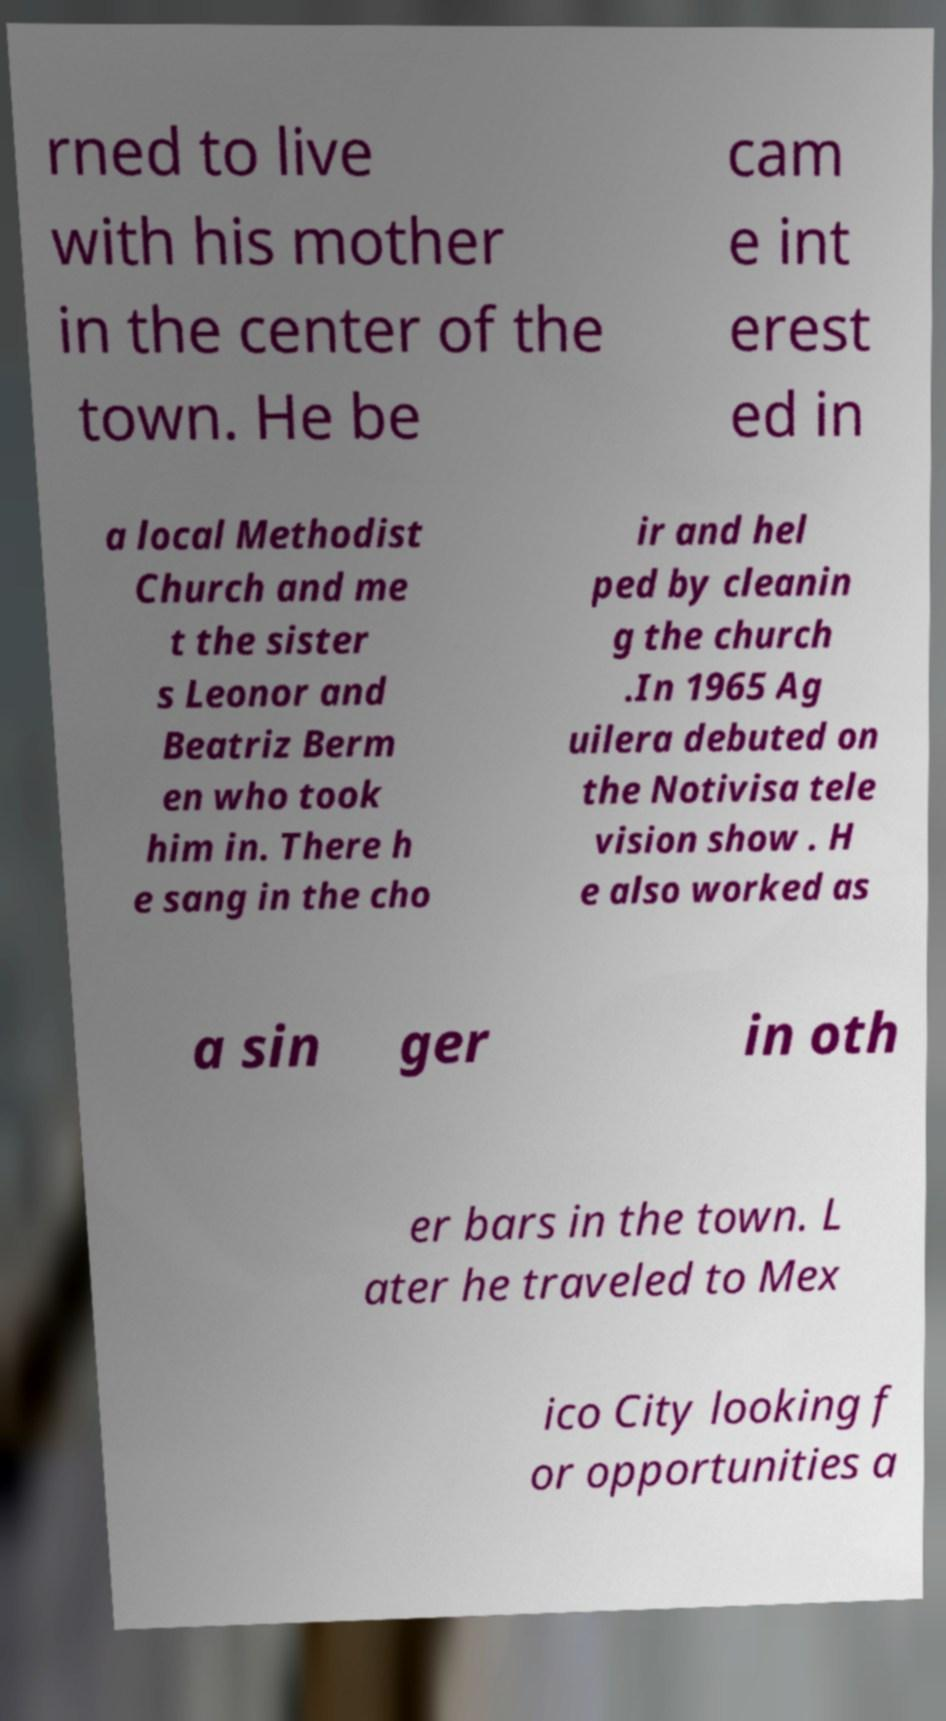There's text embedded in this image that I need extracted. Can you transcribe it verbatim? rned to live with his mother in the center of the town. He be cam e int erest ed in a local Methodist Church and me t the sister s Leonor and Beatriz Berm en who took him in. There h e sang in the cho ir and hel ped by cleanin g the church .In 1965 Ag uilera debuted on the Notivisa tele vision show . H e also worked as a sin ger in oth er bars in the town. L ater he traveled to Mex ico City looking f or opportunities a 